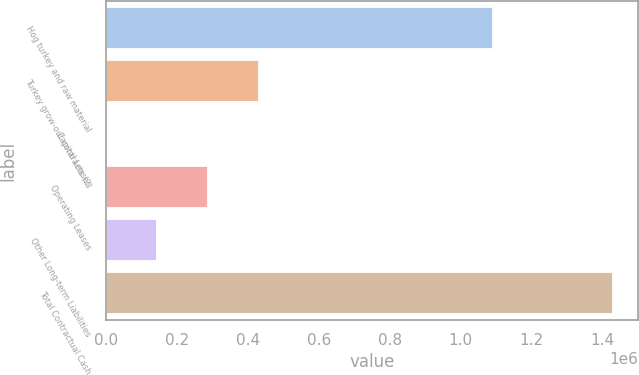<chart> <loc_0><loc_0><loc_500><loc_500><bar_chart><fcel>Hog turkey and raw material<fcel>Turkey grow-out contracts (2)<fcel>Capital Leases<fcel>Operating Leases<fcel>Other Long-term Liabilities<fcel>Total Contractual Cash<nl><fcel>1.09186e+06<fcel>431148<fcel>3496<fcel>288597<fcel>146046<fcel>1.429e+06<nl></chart> 